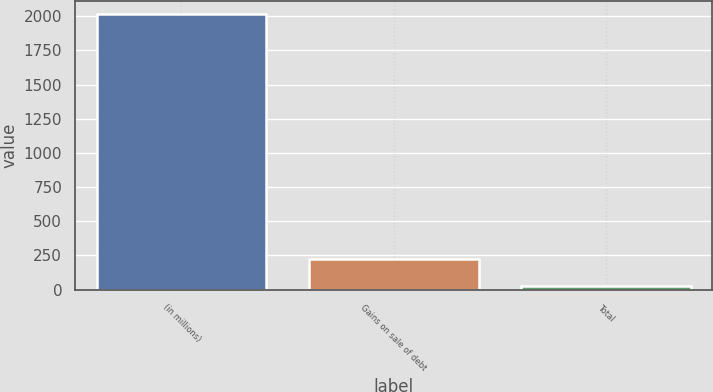Convert chart. <chart><loc_0><loc_0><loc_500><loc_500><bar_chart><fcel>(in millions)<fcel>Gains on sale of debt<fcel>Total<nl><fcel>2014<fcel>226.6<fcel>28<nl></chart> 